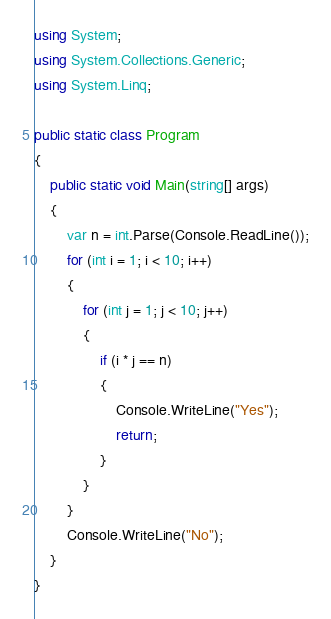<code> <loc_0><loc_0><loc_500><loc_500><_C#_>using System;
using System.Collections.Generic;
using System.Linq;

public static class Program
{
    public static void Main(string[] args)
    {
        var n = int.Parse(Console.ReadLine());
        for (int i = 1; i < 10; i++)
        {
            for (int j = 1; j < 10; j++)
            {
                if (i * j == n)
                {
                    Console.WriteLine("Yes");
                    return;
                }
            }
        }
        Console.WriteLine("No");
    }
}</code> 